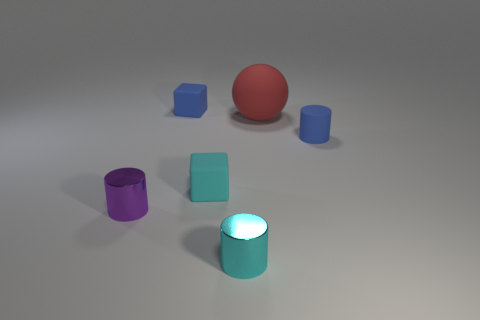Is there any other thing that has the same shape as the red rubber object?
Offer a terse response. No. Is the number of small purple metal cylinders behind the cyan matte object less than the number of cyan matte things that are on the left side of the big red object?
Offer a very short reply. Yes. The small rubber thing that is left of the tiny cyan rubber cube is what color?
Give a very brief answer. Blue. How many other things are the same color as the large object?
Provide a succinct answer. 0. There is a metallic cylinder that is left of the blue matte block; is its size the same as the blue rubber cylinder?
Offer a terse response. Yes. How many things are behind the big red ball?
Keep it short and to the point. 1. Are there any red cubes of the same size as the red sphere?
Your answer should be very brief. No. Is the big matte thing the same color as the small matte cylinder?
Offer a terse response. No. There is a cylinder on the left side of the small metal cylinder right of the small purple cylinder; what color is it?
Provide a succinct answer. Purple. How many rubber objects are both behind the cyan rubber block and left of the small blue cylinder?
Ensure brevity in your answer.  2. 